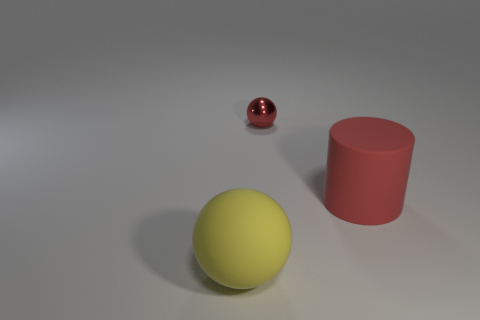Is the number of rubber objects on the right side of the red ball greater than the number of big gray rubber spheres?
Give a very brief answer. Yes. What is the object that is both left of the red cylinder and behind the large ball made of?
Make the answer very short. Metal. Is there anything else that has the same shape as the large red matte object?
Provide a short and direct response. No. How many objects are both right of the metal thing and behind the large red cylinder?
Offer a very short reply. 0. What is the material of the small thing?
Provide a succinct answer. Metal. Are there an equal number of things that are behind the big yellow sphere and large objects?
Your answer should be very brief. Yes. What number of red objects have the same shape as the yellow matte object?
Ensure brevity in your answer.  1. Is the shiny thing the same shape as the large yellow thing?
Make the answer very short. Yes. How many objects are things on the right side of the large rubber ball or large balls?
Give a very brief answer. 3. There is a big object right of the red thing behind the large object that is behind the large yellow thing; what is its shape?
Your response must be concise. Cylinder. 